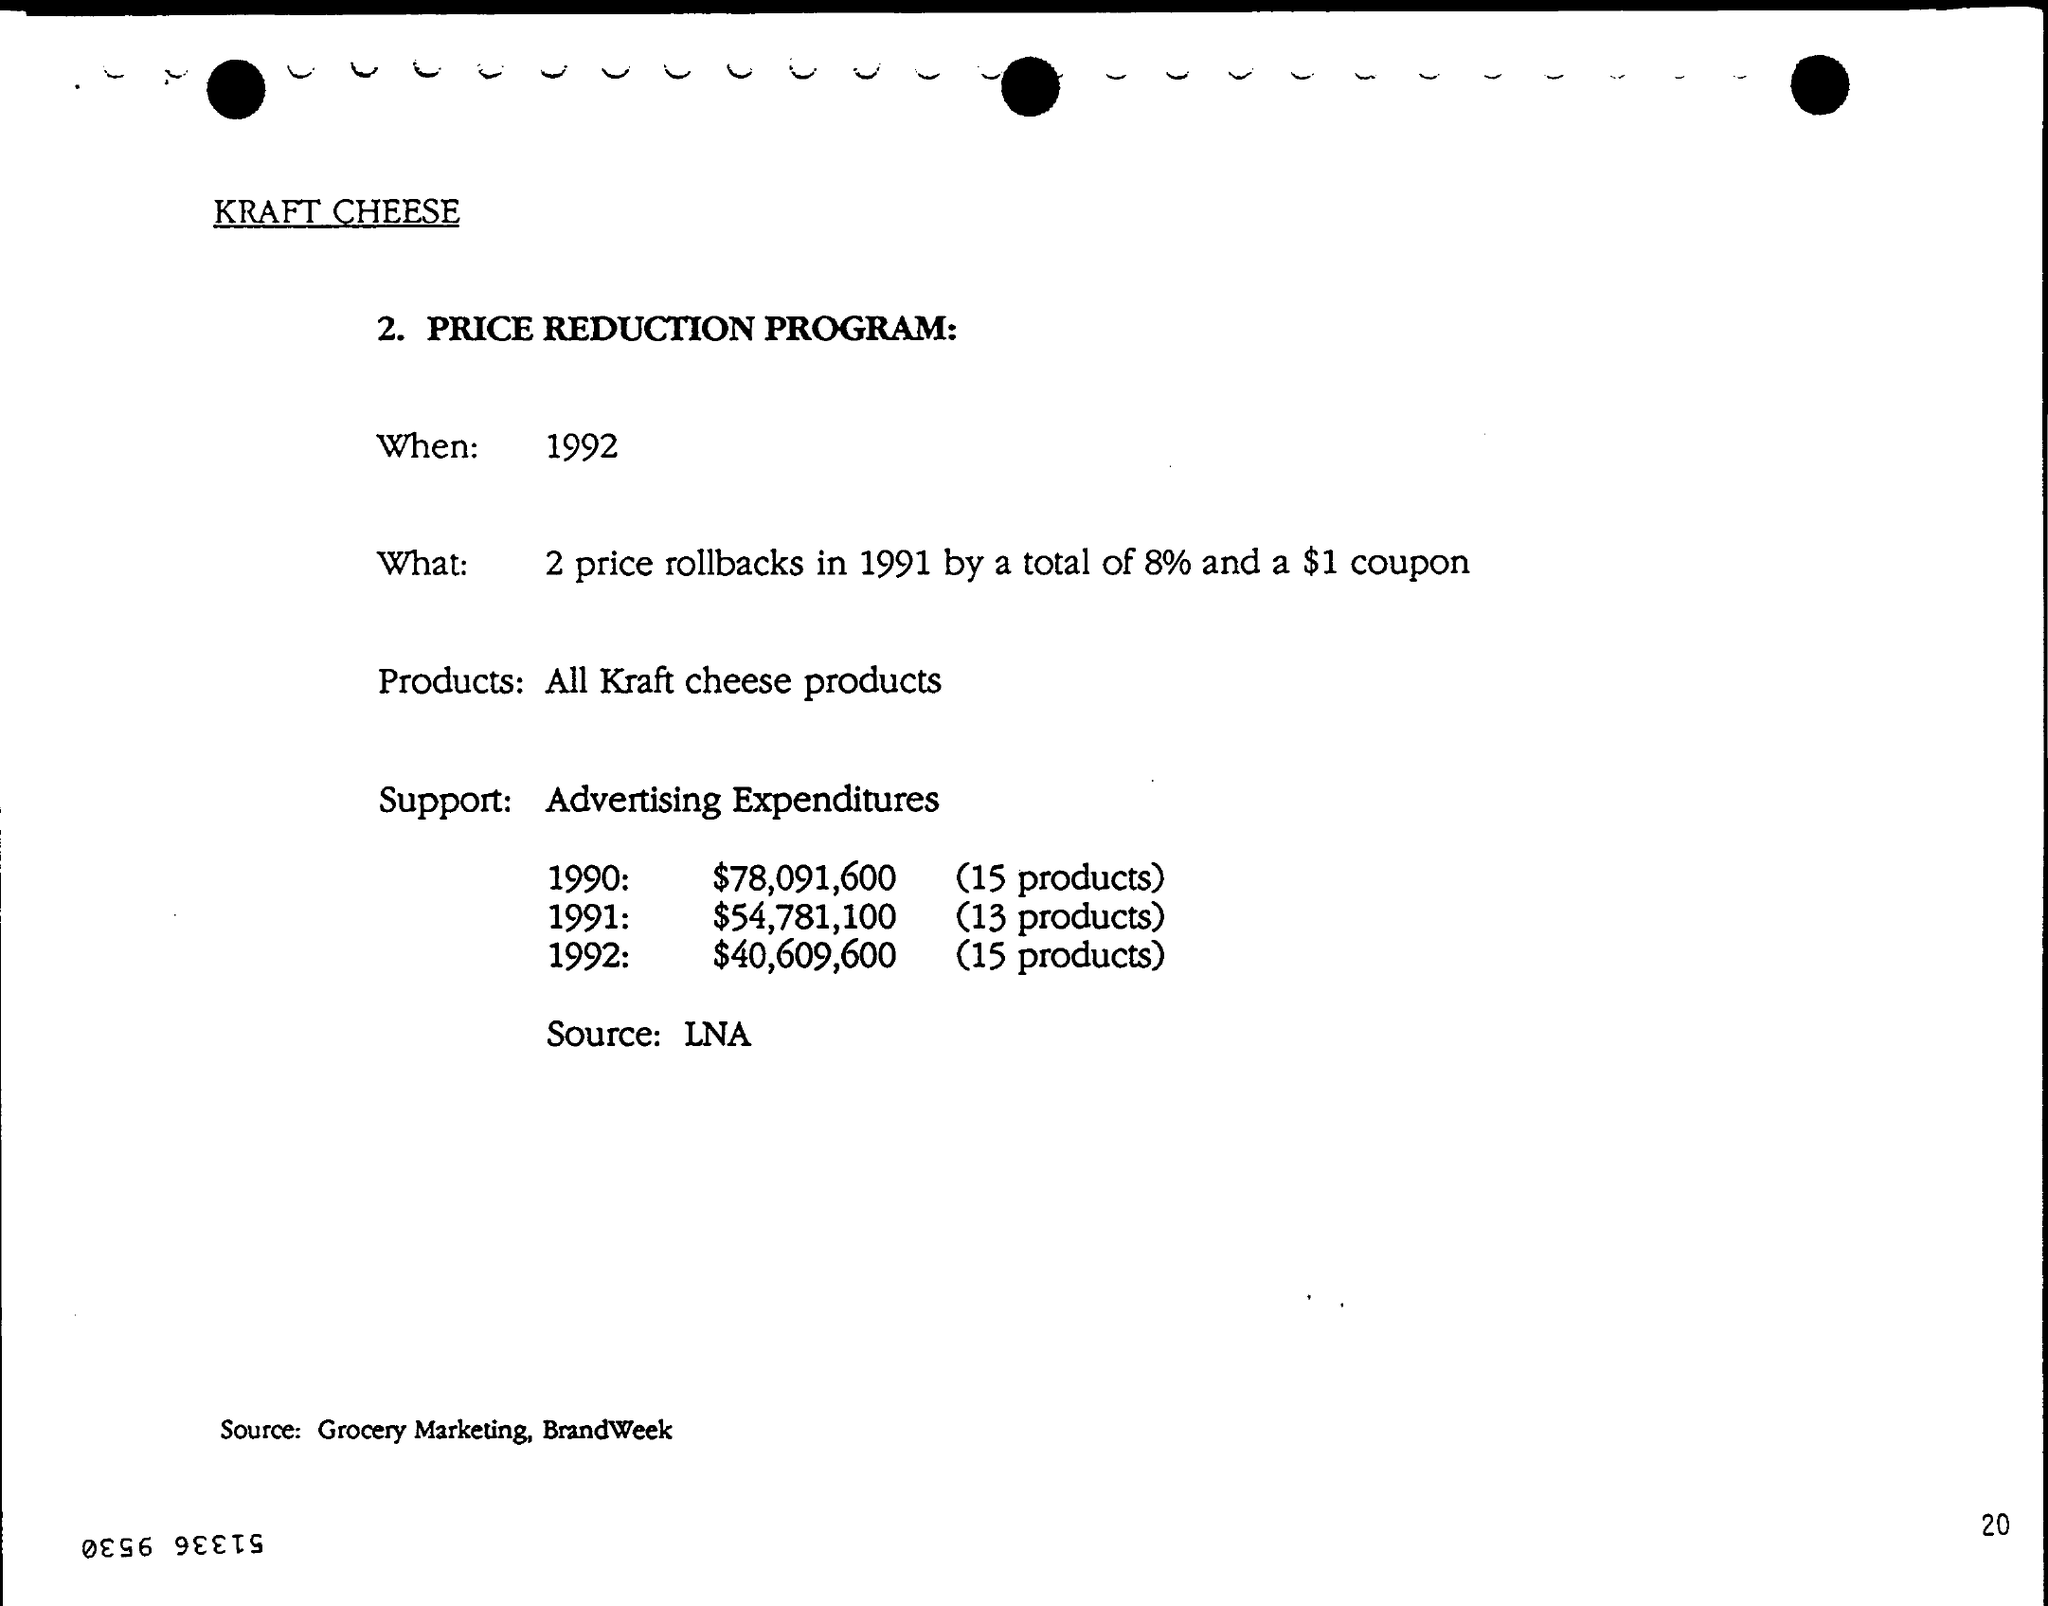Draw attention to some important aspects in this diagram. The source mentioned at the bottom of the page is Grocery Marketing and Brandweek. Kraft cheese products are included in the price reduction program, and all of them are eligible for a discount. The PRICE REDUCTION PROGRAM will take place in 1992. 